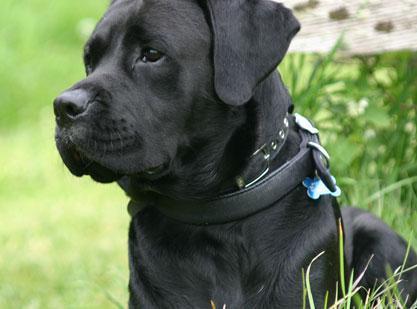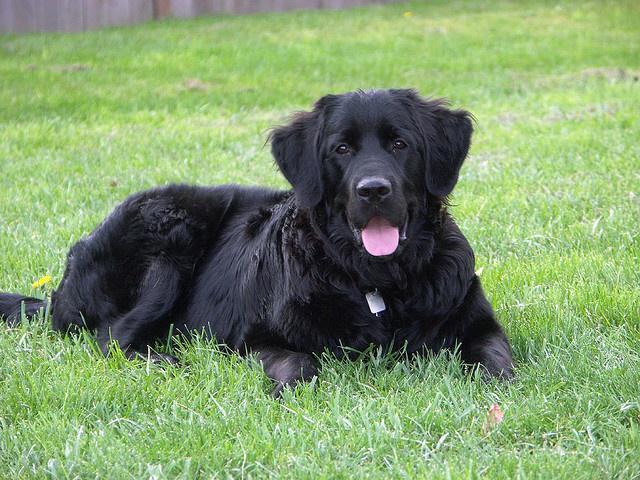The first image is the image on the left, the second image is the image on the right. For the images shown, is this caption "The right image contains two dogs that are different colors." true? Answer yes or no. No. 